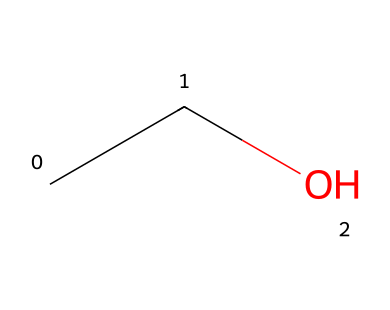What is the chemical name of this compound? The SMILES representation "CCO" corresponds to the structural formula that indicates it is ethanol, as it contains a two-carbon chain (C-C) and a hydroxyl group (OH).
Answer: ethanol How many carbon atoms are present in the molecule? The SMILES "CCO" indicates that there are two 'C' characters, representing the two carbon atoms in the structure of ethanol.
Answer: 2 What is the total number of hydrogen atoms in ethanol? For every carbon atom in ethanol, there are hydrogen atoms associated with it. The formula C2H5OH indicates there are 6 hydrogen atoms (5 in the ethyl group and 1 in the hydroxyl group).
Answer: 6 What type of functional group is present in this compound? The presence of the hydroxyl group (-OH) in the structure indicates that ethanol contains an alcohol functional group, which is characteristic of non-electrolytes.
Answer: alcohol Is ethanol a polar or nonpolar molecule? The presence of the hydroxyl group, which is polar, combined with the presence of carbon chains, makes ethanol a polar molecule overall due to its ability to form hydrogen bonds.
Answer: polar How many total bonds are present in ethanol? Analyzing "CCO", the molecule contains 2 carbon-carbon single bonds, 5 carbon-hydrogen bonds, and 1 oxygen-hydrogen bond, totaling 8 bonds in ethanol.
Answer: 8 What is ethanol's primary use in Friulano wine? Ethanol is produced during fermentation and acts as the primary alcohol that contributes to the beverage's flavor profile, aroma, and alcoholic content.
Answer: fermentation 